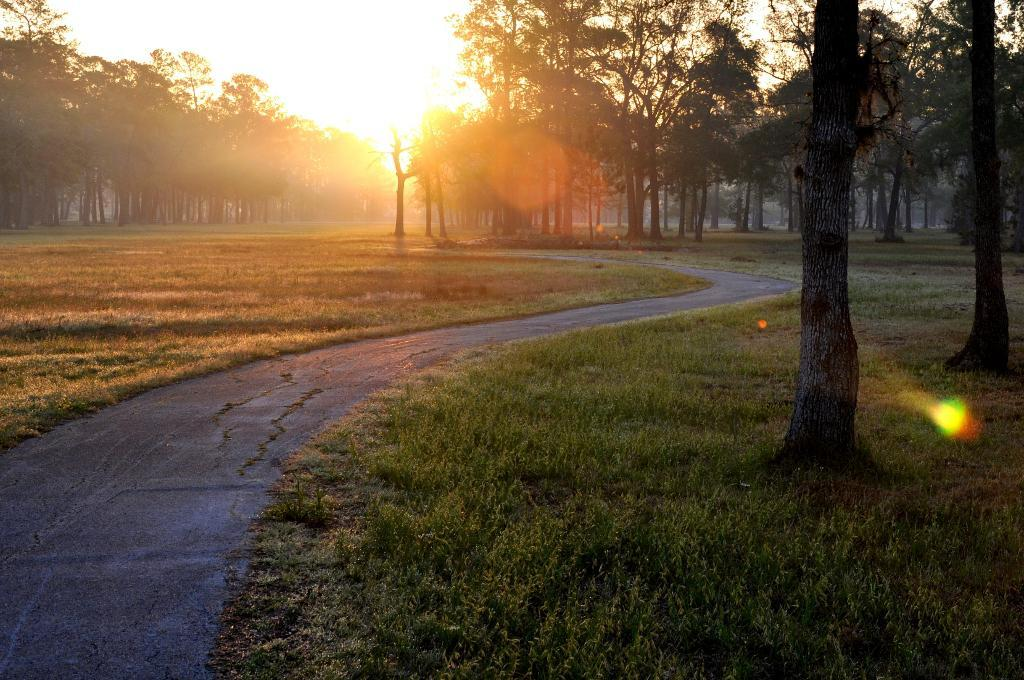What can be seen in the foreground of the image? There is a beautiful scenery in the foreground of the image. What type of vegetation is present along the path in the scenery? Trees are present on both sides of the path in the scenery. What is the main feature of the scenery? There is a path in the middle of the scenery. What is happening in the background of the image? The sun is rising in the background of the image. Can you see any eyes in the image? There are no eyes present in the image. What type of mist can be seen in the image? There is no mist present in the image. 